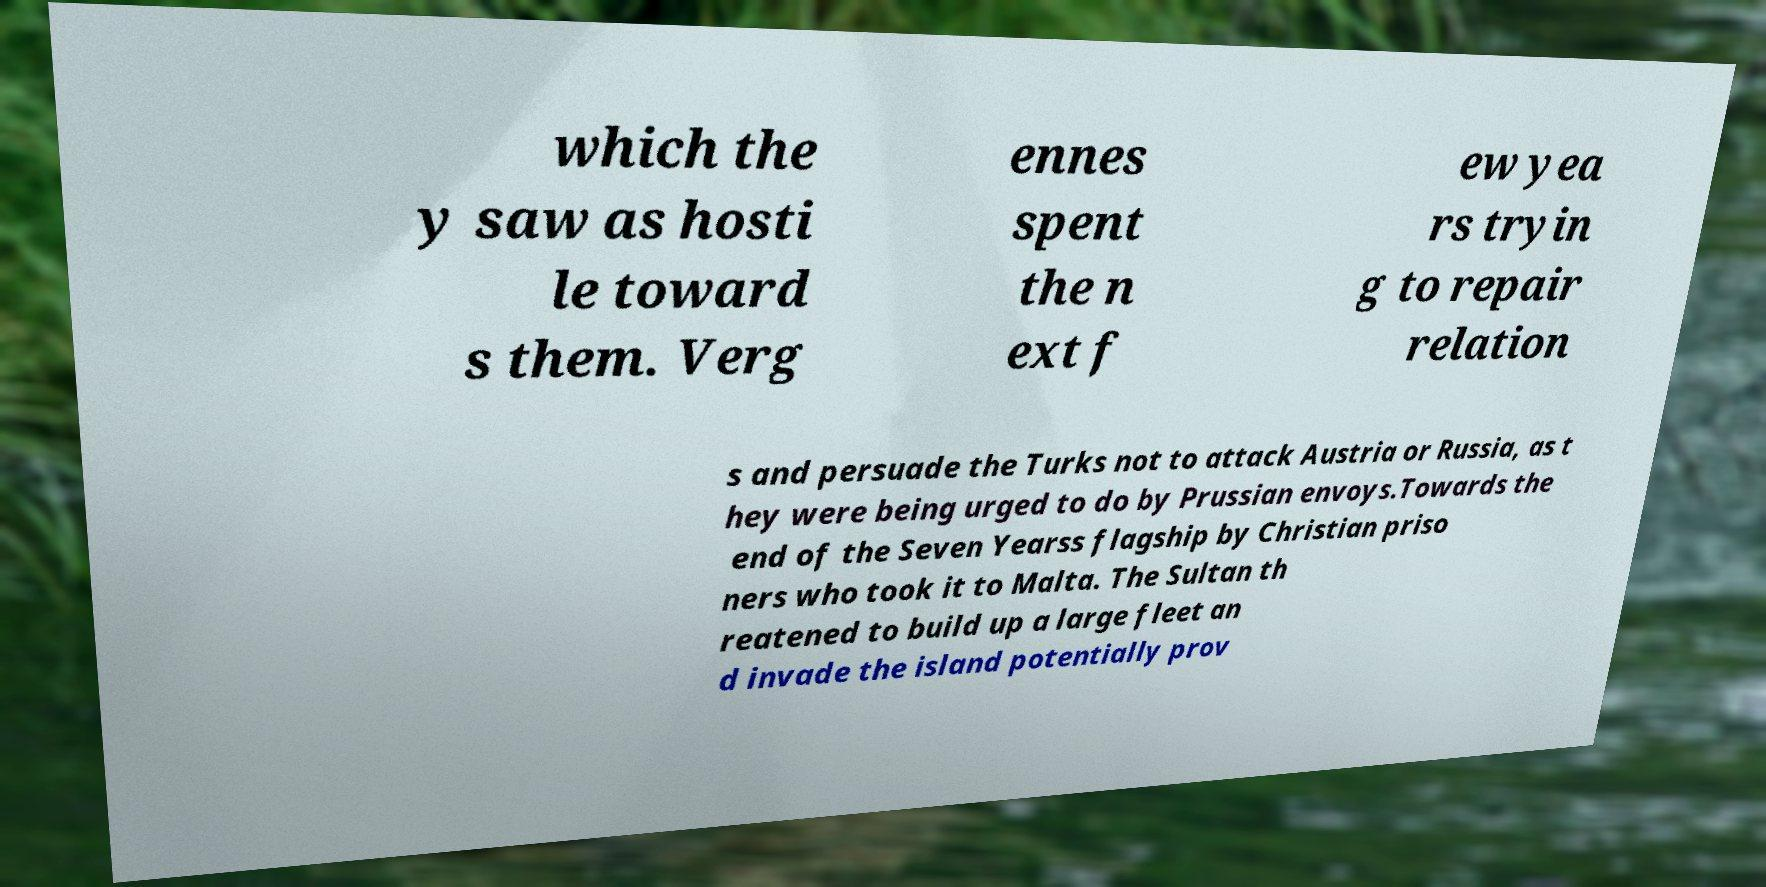Please identify and transcribe the text found in this image. which the y saw as hosti le toward s them. Verg ennes spent the n ext f ew yea rs tryin g to repair relation s and persuade the Turks not to attack Austria or Russia, as t hey were being urged to do by Prussian envoys.Towards the end of the Seven Yearss flagship by Christian priso ners who took it to Malta. The Sultan th reatened to build up a large fleet an d invade the island potentially prov 